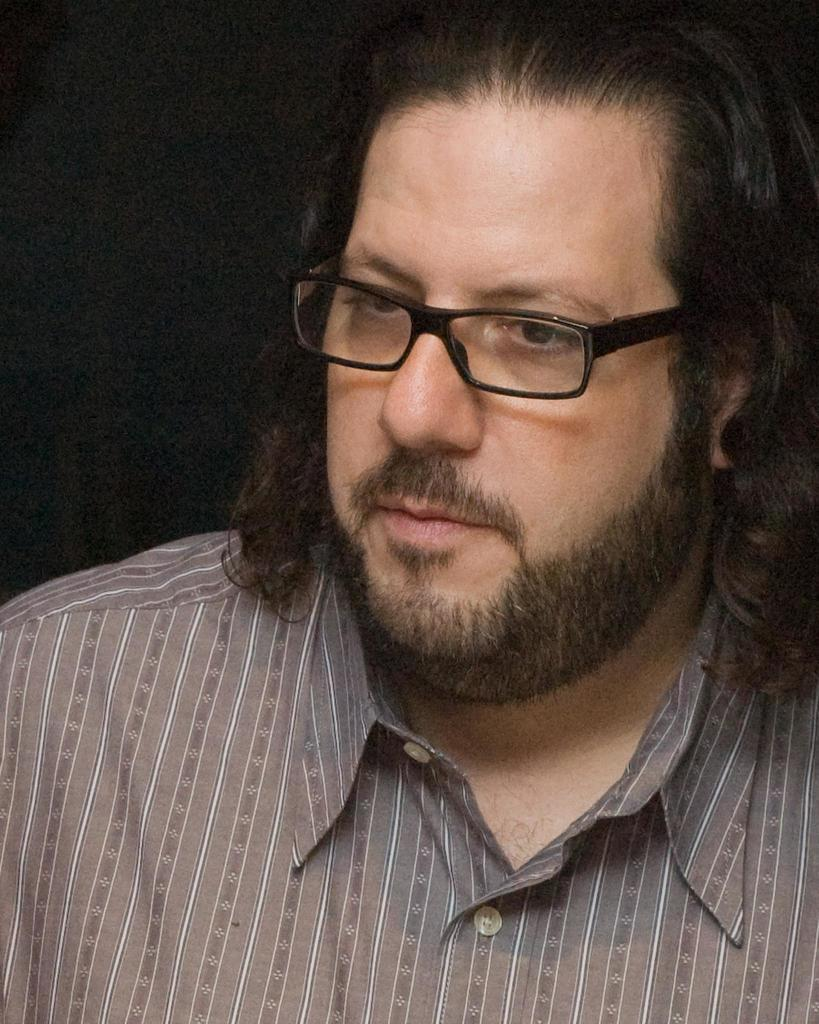Who is the main subject in the image? There is a man in the picture. What can be observed about the man's appearance? The man is wearing spectacles. What is the color or lighting condition of the background in the image? The background of the image is dark. What type of weather can be seen in the image? There is no indication of weather in the image, as it only features a man wearing spectacles against a dark background. 